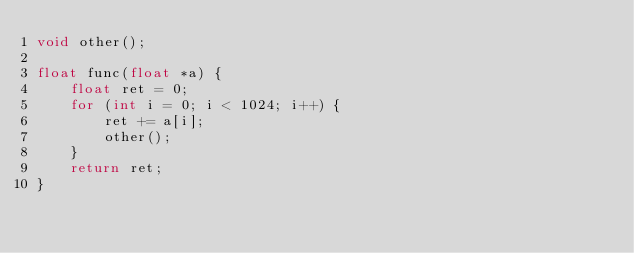<code> <loc_0><loc_0><loc_500><loc_500><_C++_>void other();

float func(float *a) {
    float ret = 0;
    for (int i = 0; i < 1024; i++) {
        ret += a[i];
        other();
    }
    return ret;
}
</code> 